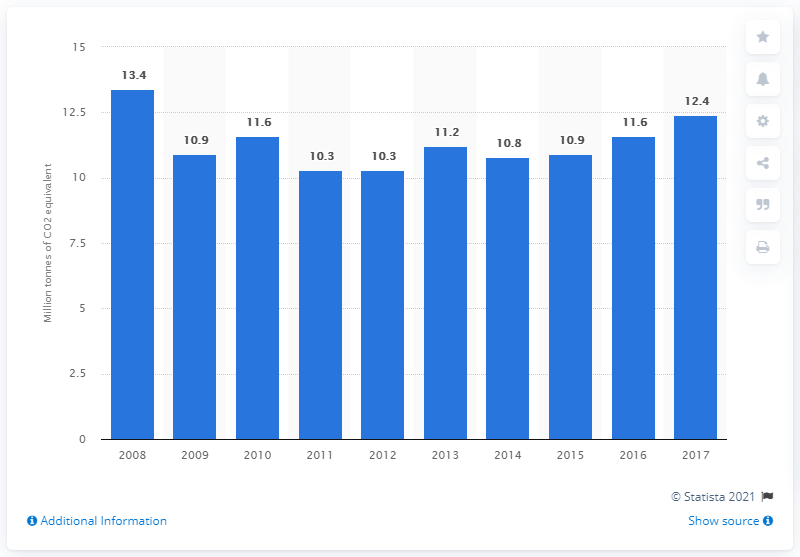Give some essential details in this illustration. In 2017, Italy emitted approximately 12.4 million metric tons of CO2 equivalent, which is a measure of the greenhouse gas emissions. In 2008, the Italian chemical industry emitted approximately 13.4 metric tons of CO2 equivalent greenhouse gases. 